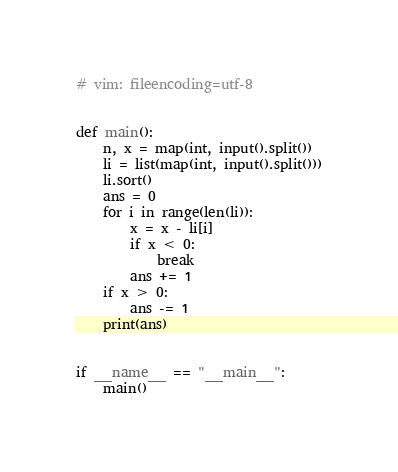Convert code to text. <code><loc_0><loc_0><loc_500><loc_500><_Python_># vim: fileencoding=utf-8


def main():
    n, x = map(int, input().split())
    li = list(map(int, input().split()))
    li.sort()
    ans = 0
    for i in range(len(li)):
        x = x - li[i]
        if x < 0:
            break
        ans += 1
    if x > 0:
        ans -= 1
    print(ans)


if __name__ == "__main__":
    main()
</code> 